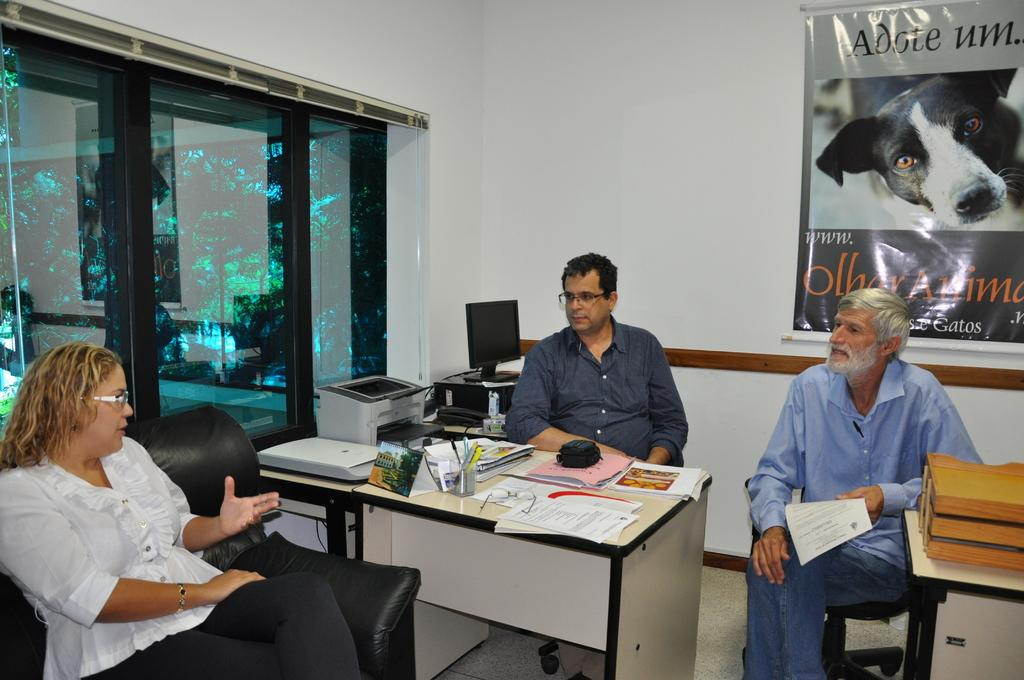Who or what can be seen in the image? There are people in the image. What are the people doing in the image? The people are sitting on chairs and sofas. What type of game is being played in the image? There is no game being played in the image; it only shows people sitting on chairs and sofas. What kind of pies are being served in the image? There are no pies present in the image. 